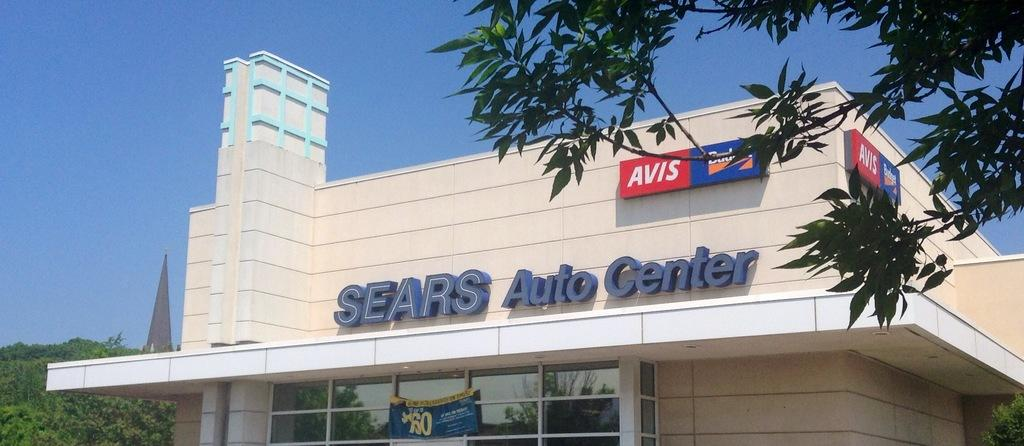<image>
Render a clear and concise summary of the photo. A store front of Sears Auto Center in a sunny day. 